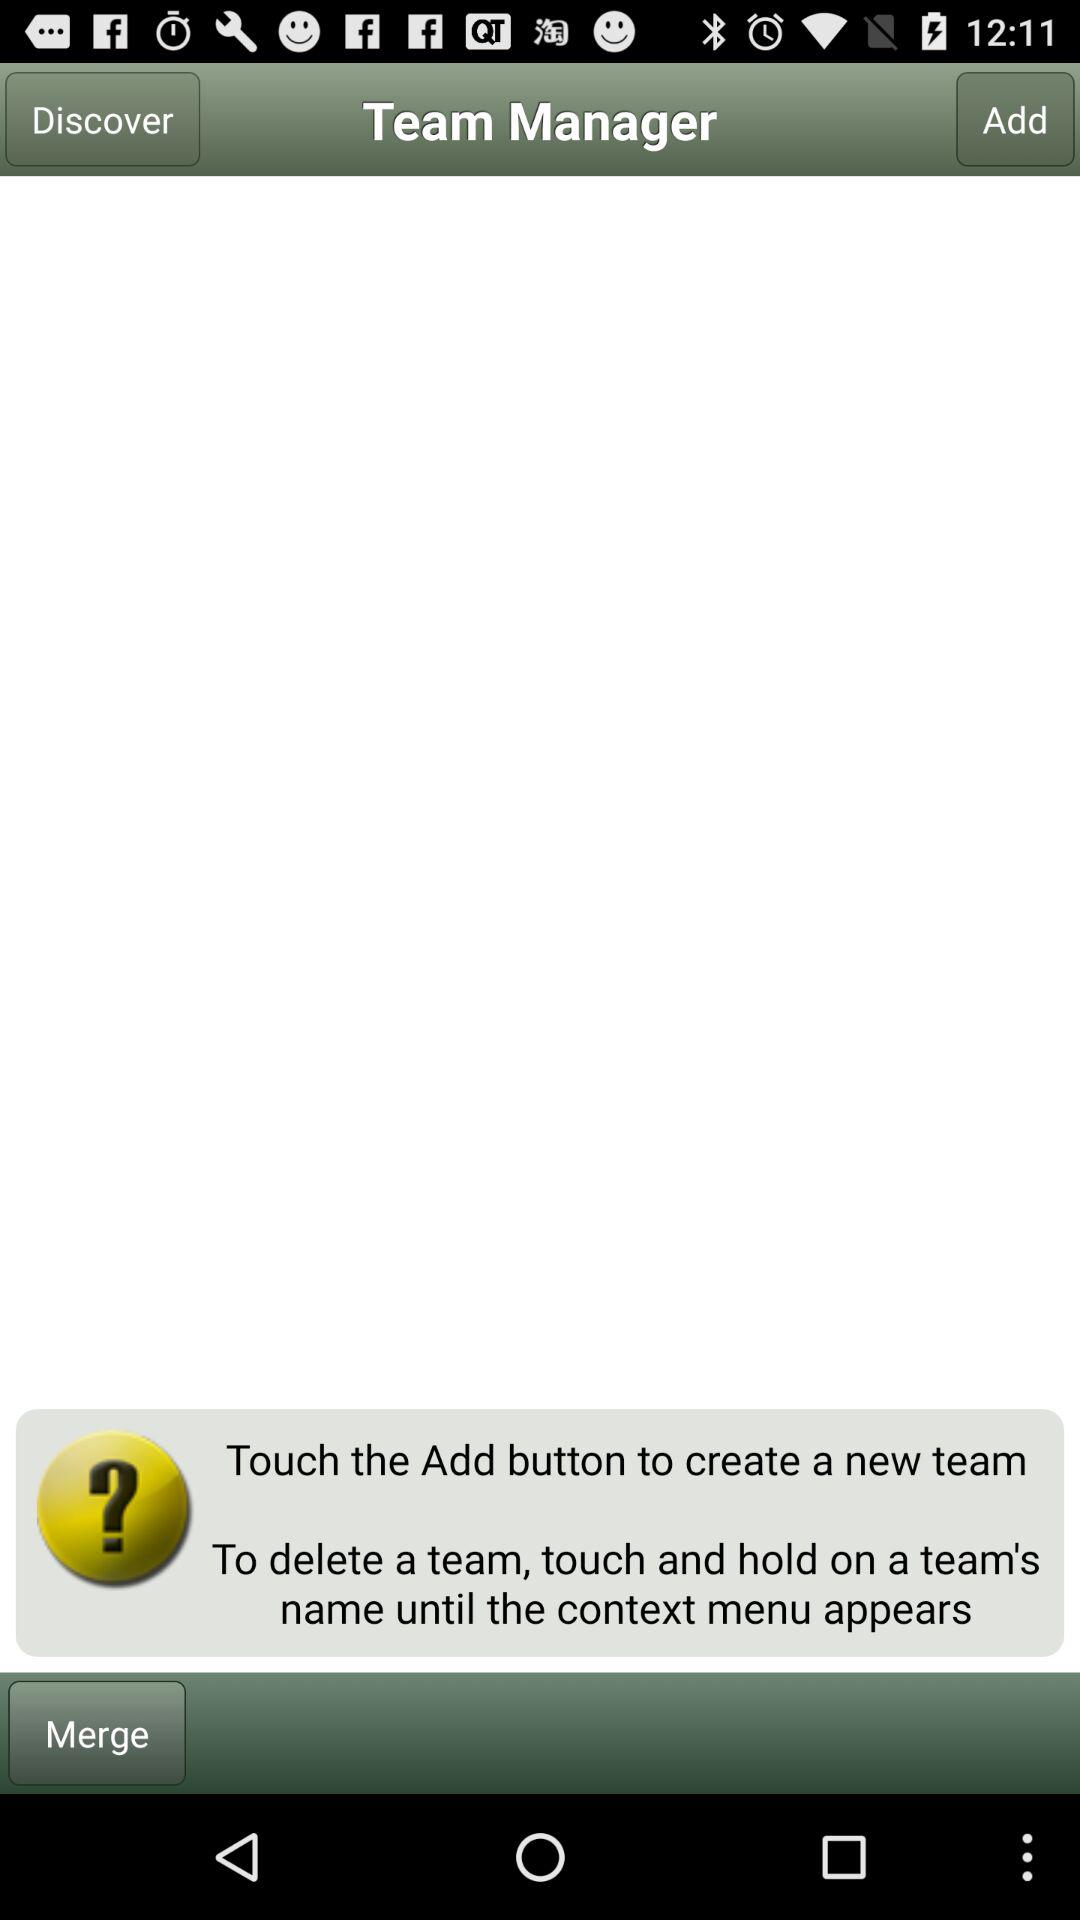How can we create a new team? You can create a new team by touching the "Add" button. 